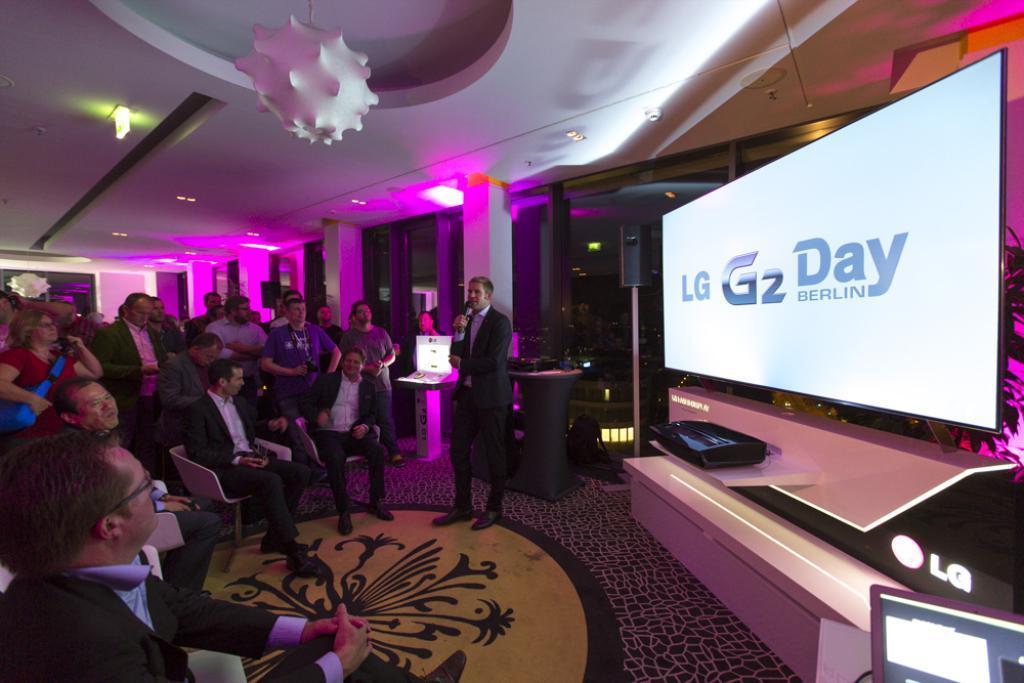Can you describe this image briefly? In this picture I can see there are a group of people sitting in the chairs at left side and there is a man standing here and he is wearing a 